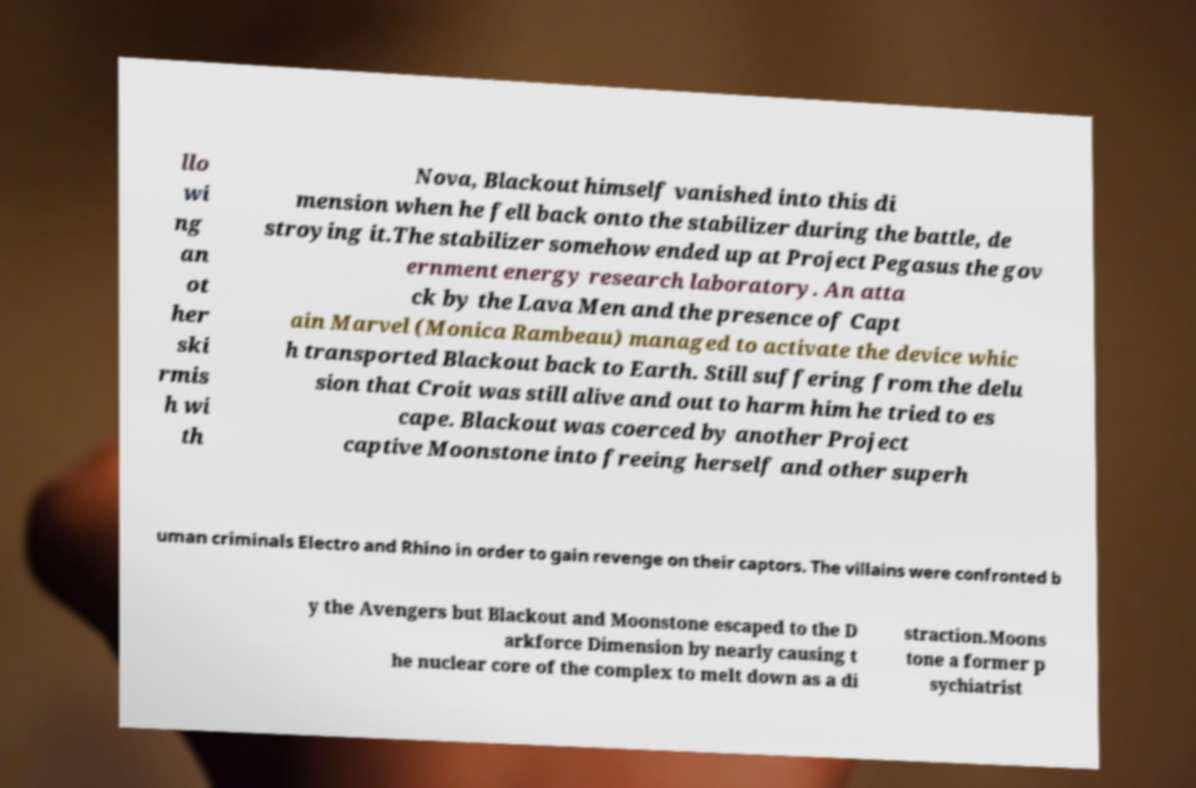Please identify and transcribe the text found in this image. llo wi ng an ot her ski rmis h wi th Nova, Blackout himself vanished into this di mension when he fell back onto the stabilizer during the battle, de stroying it.The stabilizer somehow ended up at Project Pegasus the gov ernment energy research laboratory. An atta ck by the Lava Men and the presence of Capt ain Marvel (Monica Rambeau) managed to activate the device whic h transported Blackout back to Earth. Still suffering from the delu sion that Croit was still alive and out to harm him he tried to es cape. Blackout was coerced by another Project captive Moonstone into freeing herself and other superh uman criminals Electro and Rhino in order to gain revenge on their captors. The villains were confronted b y the Avengers but Blackout and Moonstone escaped to the D arkforce Dimension by nearly causing t he nuclear core of the complex to melt down as a di straction.Moons tone a former p sychiatrist 